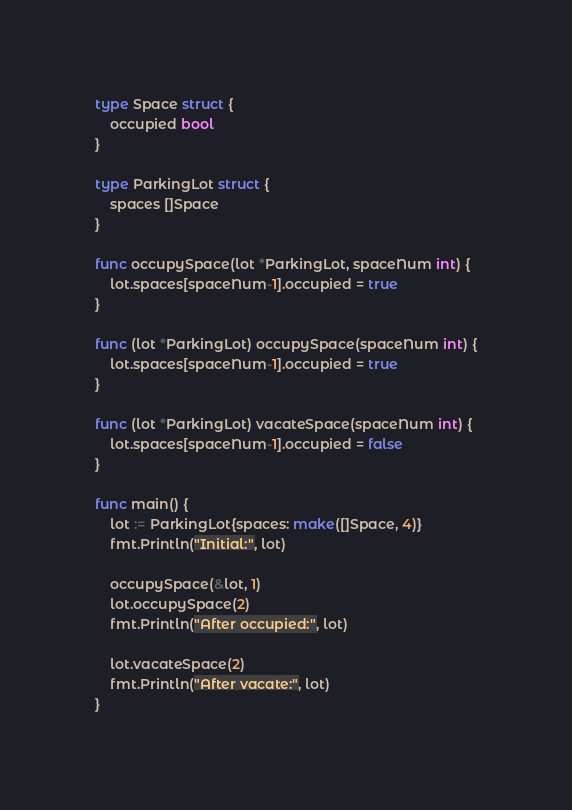Convert code to text. <code><loc_0><loc_0><loc_500><loc_500><_Go_>
type Space struct {
	occupied bool
}

type ParkingLot struct {
	spaces []Space
}

func occupySpace(lot *ParkingLot, spaceNum int) {
	lot.spaces[spaceNum-1].occupied = true
}

func (lot *ParkingLot) occupySpace(spaceNum int) {
	lot.spaces[spaceNum-1].occupied = true
}

func (lot *ParkingLot) vacateSpace(spaceNum int) {
	lot.spaces[spaceNum-1].occupied = false
}

func main() {
	lot := ParkingLot{spaces: make([]Space, 4)}
	fmt.Println("Initial:", lot)

	occupySpace(&lot, 1)
	lot.occupySpace(2)
	fmt.Println("After occupied:", lot)

	lot.vacateSpace(2)
	fmt.Println("After vacate:", lot)
}
</code> 